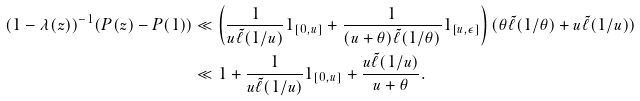Convert formula to latex. <formula><loc_0><loc_0><loc_500><loc_500>( 1 - \lambda ( z ) ) ^ { - 1 } ( P ( z ) - P ( 1 ) ) & \ll \left ( \frac { 1 } { u \tilde { \ell } ( 1 / u ) } 1 _ { [ 0 , u ] } + \frac { 1 } { ( u + \theta ) \tilde { \ell } ( 1 / \theta ) } 1 _ { [ u , \epsilon ] } \right ) ( \theta \tilde { \ell } ( 1 / \theta ) + u \tilde { \ell } ( 1 / u ) ) \\ & \ll 1 + \frac { 1 } { u \tilde { \ell } ( 1 / u ) } 1 _ { [ 0 , u ] } + \frac { u \tilde { \ell } ( 1 / u ) } { u + \theta } .</formula> 